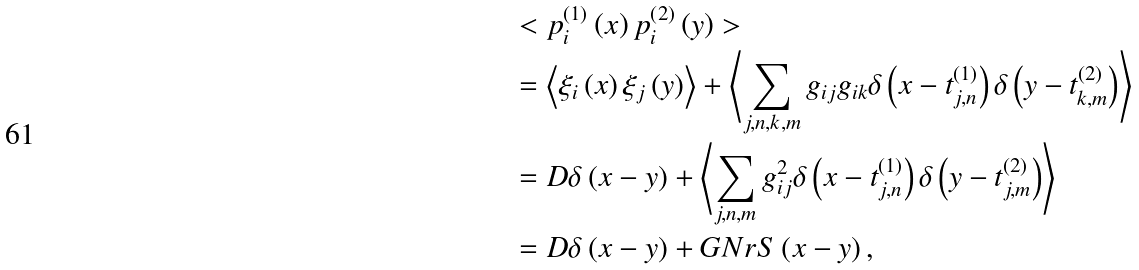Convert formula to latex. <formula><loc_0><loc_0><loc_500><loc_500>& < p _ { i } ^ { \left ( 1 \right ) } \left ( x \right ) p _ { i } ^ { \left ( 2 \right ) } \left ( y \right ) > \\ & = \left < \xi _ { i } \left ( x \right ) \xi _ { j } \left ( y \right ) \right > + \left < \sum _ { j , n , k , m } g _ { i j } g _ { i k } \delta \left ( x - t _ { j , n } ^ { \left ( 1 \right ) } \right ) \delta \left ( y - t _ { k , m } ^ { \left ( 2 \right ) } \right ) \right > \\ & = D \delta \left ( x - y \right ) + \left < \sum _ { j , n , m } g _ { i j } ^ { 2 } \delta \left ( x - t _ { j , n } ^ { \left ( 1 \right ) } \right ) \delta \left ( y - t _ { j , m } ^ { \left ( 2 \right ) } \right ) \right > \\ & = D \delta \left ( x - y \right ) + G N r S \left ( x - y \right ) ,</formula> 